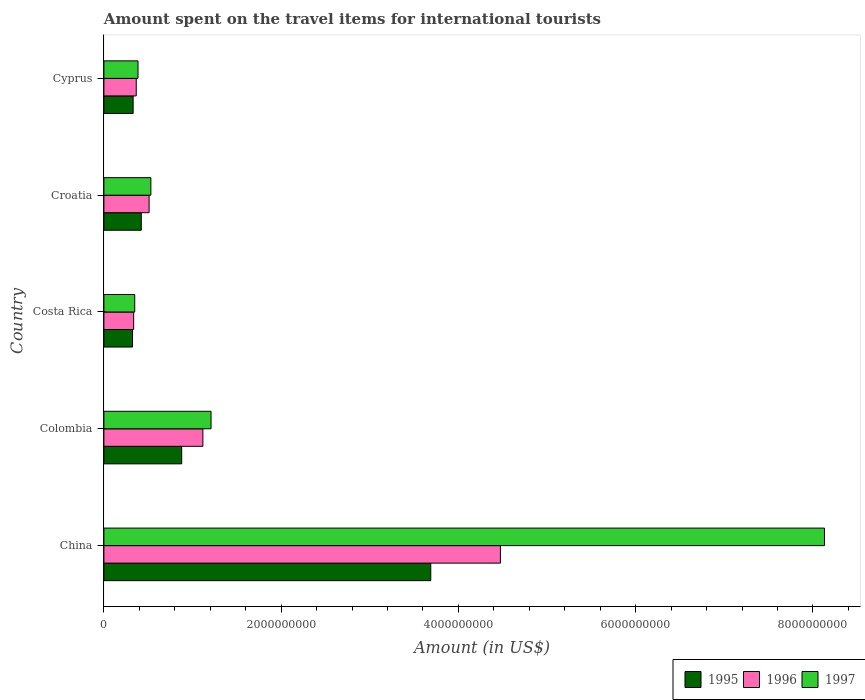How many different coloured bars are there?
Offer a terse response. 3. How many groups of bars are there?
Offer a terse response. 5. Are the number of bars on each tick of the Y-axis equal?
Your response must be concise. Yes. How many bars are there on the 5th tick from the top?
Provide a short and direct response. 3. What is the amount spent on the travel items for international tourists in 1995 in China?
Provide a short and direct response. 3.69e+09. Across all countries, what is the maximum amount spent on the travel items for international tourists in 1996?
Provide a short and direct response. 4.47e+09. Across all countries, what is the minimum amount spent on the travel items for international tourists in 1995?
Provide a short and direct response. 3.23e+08. In which country was the amount spent on the travel items for international tourists in 1996 minimum?
Provide a succinct answer. Costa Rica. What is the total amount spent on the travel items for international tourists in 1997 in the graph?
Offer a very short reply. 1.06e+1. What is the difference between the amount spent on the travel items for international tourists in 1995 in Costa Rica and that in Croatia?
Your answer should be very brief. -9.90e+07. What is the difference between the amount spent on the travel items for international tourists in 1997 in Costa Rica and the amount spent on the travel items for international tourists in 1995 in Colombia?
Keep it short and to the point. -5.30e+08. What is the average amount spent on the travel items for international tourists in 1996 per country?
Offer a very short reply. 1.36e+09. What is the difference between the amount spent on the travel items for international tourists in 1997 and amount spent on the travel items for international tourists in 1996 in China?
Your answer should be compact. 3.66e+09. In how many countries, is the amount spent on the travel items for international tourists in 1996 greater than 2400000000 US$?
Offer a very short reply. 1. What is the ratio of the amount spent on the travel items for international tourists in 1995 in Colombia to that in Cyprus?
Your answer should be very brief. 2.66. Is the difference between the amount spent on the travel items for international tourists in 1997 in China and Cyprus greater than the difference between the amount spent on the travel items for international tourists in 1996 in China and Cyprus?
Ensure brevity in your answer.  Yes. What is the difference between the highest and the second highest amount spent on the travel items for international tourists in 1996?
Keep it short and to the point. 3.36e+09. What is the difference between the highest and the lowest amount spent on the travel items for international tourists in 1995?
Offer a terse response. 3.36e+09. Is the sum of the amount spent on the travel items for international tourists in 1995 in China and Colombia greater than the maximum amount spent on the travel items for international tourists in 1997 across all countries?
Ensure brevity in your answer.  No. What does the 3rd bar from the top in Cyprus represents?
Your answer should be very brief. 1995. What does the 1st bar from the bottom in China represents?
Your answer should be compact. 1995. How many countries are there in the graph?
Your answer should be compact. 5. Are the values on the major ticks of X-axis written in scientific E-notation?
Your response must be concise. No. Does the graph contain any zero values?
Offer a terse response. No. Where does the legend appear in the graph?
Give a very brief answer. Bottom right. How many legend labels are there?
Offer a very short reply. 3. What is the title of the graph?
Give a very brief answer. Amount spent on the travel items for international tourists. Does "1961" appear as one of the legend labels in the graph?
Your response must be concise. No. What is the Amount (in US$) in 1995 in China?
Give a very brief answer. 3.69e+09. What is the Amount (in US$) in 1996 in China?
Your response must be concise. 4.47e+09. What is the Amount (in US$) of 1997 in China?
Your answer should be compact. 8.13e+09. What is the Amount (in US$) of 1995 in Colombia?
Offer a very short reply. 8.78e+08. What is the Amount (in US$) in 1996 in Colombia?
Ensure brevity in your answer.  1.12e+09. What is the Amount (in US$) in 1997 in Colombia?
Offer a very short reply. 1.21e+09. What is the Amount (in US$) of 1995 in Costa Rica?
Your response must be concise. 3.23e+08. What is the Amount (in US$) of 1996 in Costa Rica?
Offer a terse response. 3.36e+08. What is the Amount (in US$) of 1997 in Costa Rica?
Provide a succinct answer. 3.48e+08. What is the Amount (in US$) in 1995 in Croatia?
Ensure brevity in your answer.  4.22e+08. What is the Amount (in US$) of 1996 in Croatia?
Your answer should be compact. 5.10e+08. What is the Amount (in US$) in 1997 in Croatia?
Ensure brevity in your answer.  5.30e+08. What is the Amount (in US$) in 1995 in Cyprus?
Provide a short and direct response. 3.30e+08. What is the Amount (in US$) of 1996 in Cyprus?
Your answer should be compact. 3.65e+08. What is the Amount (in US$) of 1997 in Cyprus?
Your answer should be compact. 3.85e+08. Across all countries, what is the maximum Amount (in US$) of 1995?
Provide a succinct answer. 3.69e+09. Across all countries, what is the maximum Amount (in US$) in 1996?
Make the answer very short. 4.47e+09. Across all countries, what is the maximum Amount (in US$) of 1997?
Offer a terse response. 8.13e+09. Across all countries, what is the minimum Amount (in US$) of 1995?
Ensure brevity in your answer.  3.23e+08. Across all countries, what is the minimum Amount (in US$) in 1996?
Keep it short and to the point. 3.36e+08. Across all countries, what is the minimum Amount (in US$) in 1997?
Offer a very short reply. 3.48e+08. What is the total Amount (in US$) of 1995 in the graph?
Give a very brief answer. 5.64e+09. What is the total Amount (in US$) of 1996 in the graph?
Provide a short and direct response. 6.80e+09. What is the total Amount (in US$) in 1997 in the graph?
Your answer should be compact. 1.06e+1. What is the difference between the Amount (in US$) of 1995 in China and that in Colombia?
Make the answer very short. 2.81e+09. What is the difference between the Amount (in US$) in 1996 in China and that in Colombia?
Provide a succinct answer. 3.36e+09. What is the difference between the Amount (in US$) of 1997 in China and that in Colombia?
Provide a succinct answer. 6.92e+09. What is the difference between the Amount (in US$) in 1995 in China and that in Costa Rica?
Provide a short and direct response. 3.36e+09. What is the difference between the Amount (in US$) of 1996 in China and that in Costa Rica?
Make the answer very short. 4.14e+09. What is the difference between the Amount (in US$) of 1997 in China and that in Costa Rica?
Give a very brief answer. 7.78e+09. What is the difference between the Amount (in US$) of 1995 in China and that in Croatia?
Your answer should be compact. 3.27e+09. What is the difference between the Amount (in US$) of 1996 in China and that in Croatia?
Your answer should be very brief. 3.96e+09. What is the difference between the Amount (in US$) of 1997 in China and that in Croatia?
Ensure brevity in your answer.  7.60e+09. What is the difference between the Amount (in US$) in 1995 in China and that in Cyprus?
Keep it short and to the point. 3.36e+09. What is the difference between the Amount (in US$) in 1996 in China and that in Cyprus?
Provide a succinct answer. 4.11e+09. What is the difference between the Amount (in US$) in 1997 in China and that in Cyprus?
Provide a succinct answer. 7.74e+09. What is the difference between the Amount (in US$) in 1995 in Colombia and that in Costa Rica?
Ensure brevity in your answer.  5.55e+08. What is the difference between the Amount (in US$) of 1996 in Colombia and that in Costa Rica?
Your answer should be very brief. 7.81e+08. What is the difference between the Amount (in US$) of 1997 in Colombia and that in Costa Rica?
Ensure brevity in your answer.  8.61e+08. What is the difference between the Amount (in US$) in 1995 in Colombia and that in Croatia?
Give a very brief answer. 4.56e+08. What is the difference between the Amount (in US$) in 1996 in Colombia and that in Croatia?
Your answer should be compact. 6.07e+08. What is the difference between the Amount (in US$) in 1997 in Colombia and that in Croatia?
Your answer should be very brief. 6.79e+08. What is the difference between the Amount (in US$) of 1995 in Colombia and that in Cyprus?
Your answer should be very brief. 5.48e+08. What is the difference between the Amount (in US$) of 1996 in Colombia and that in Cyprus?
Give a very brief answer. 7.52e+08. What is the difference between the Amount (in US$) in 1997 in Colombia and that in Cyprus?
Make the answer very short. 8.24e+08. What is the difference between the Amount (in US$) of 1995 in Costa Rica and that in Croatia?
Offer a very short reply. -9.90e+07. What is the difference between the Amount (in US$) in 1996 in Costa Rica and that in Croatia?
Your response must be concise. -1.74e+08. What is the difference between the Amount (in US$) in 1997 in Costa Rica and that in Croatia?
Make the answer very short. -1.82e+08. What is the difference between the Amount (in US$) of 1995 in Costa Rica and that in Cyprus?
Your answer should be very brief. -7.00e+06. What is the difference between the Amount (in US$) of 1996 in Costa Rica and that in Cyprus?
Your response must be concise. -2.90e+07. What is the difference between the Amount (in US$) in 1997 in Costa Rica and that in Cyprus?
Provide a short and direct response. -3.70e+07. What is the difference between the Amount (in US$) of 1995 in Croatia and that in Cyprus?
Your response must be concise. 9.20e+07. What is the difference between the Amount (in US$) of 1996 in Croatia and that in Cyprus?
Your answer should be compact. 1.45e+08. What is the difference between the Amount (in US$) in 1997 in Croatia and that in Cyprus?
Your answer should be very brief. 1.45e+08. What is the difference between the Amount (in US$) in 1995 in China and the Amount (in US$) in 1996 in Colombia?
Give a very brief answer. 2.57e+09. What is the difference between the Amount (in US$) of 1995 in China and the Amount (in US$) of 1997 in Colombia?
Offer a very short reply. 2.48e+09. What is the difference between the Amount (in US$) of 1996 in China and the Amount (in US$) of 1997 in Colombia?
Offer a very short reply. 3.26e+09. What is the difference between the Amount (in US$) of 1995 in China and the Amount (in US$) of 1996 in Costa Rica?
Make the answer very short. 3.35e+09. What is the difference between the Amount (in US$) in 1995 in China and the Amount (in US$) in 1997 in Costa Rica?
Make the answer very short. 3.34e+09. What is the difference between the Amount (in US$) of 1996 in China and the Amount (in US$) of 1997 in Costa Rica?
Give a very brief answer. 4.13e+09. What is the difference between the Amount (in US$) of 1995 in China and the Amount (in US$) of 1996 in Croatia?
Provide a succinct answer. 3.18e+09. What is the difference between the Amount (in US$) in 1995 in China and the Amount (in US$) in 1997 in Croatia?
Offer a very short reply. 3.16e+09. What is the difference between the Amount (in US$) of 1996 in China and the Amount (in US$) of 1997 in Croatia?
Your response must be concise. 3.94e+09. What is the difference between the Amount (in US$) in 1995 in China and the Amount (in US$) in 1996 in Cyprus?
Keep it short and to the point. 3.32e+09. What is the difference between the Amount (in US$) of 1995 in China and the Amount (in US$) of 1997 in Cyprus?
Offer a very short reply. 3.30e+09. What is the difference between the Amount (in US$) of 1996 in China and the Amount (in US$) of 1997 in Cyprus?
Your answer should be compact. 4.09e+09. What is the difference between the Amount (in US$) of 1995 in Colombia and the Amount (in US$) of 1996 in Costa Rica?
Your answer should be compact. 5.42e+08. What is the difference between the Amount (in US$) in 1995 in Colombia and the Amount (in US$) in 1997 in Costa Rica?
Provide a short and direct response. 5.30e+08. What is the difference between the Amount (in US$) in 1996 in Colombia and the Amount (in US$) in 1997 in Costa Rica?
Your answer should be very brief. 7.69e+08. What is the difference between the Amount (in US$) in 1995 in Colombia and the Amount (in US$) in 1996 in Croatia?
Make the answer very short. 3.68e+08. What is the difference between the Amount (in US$) in 1995 in Colombia and the Amount (in US$) in 1997 in Croatia?
Your answer should be compact. 3.48e+08. What is the difference between the Amount (in US$) of 1996 in Colombia and the Amount (in US$) of 1997 in Croatia?
Provide a succinct answer. 5.87e+08. What is the difference between the Amount (in US$) in 1995 in Colombia and the Amount (in US$) in 1996 in Cyprus?
Ensure brevity in your answer.  5.13e+08. What is the difference between the Amount (in US$) in 1995 in Colombia and the Amount (in US$) in 1997 in Cyprus?
Offer a terse response. 4.93e+08. What is the difference between the Amount (in US$) in 1996 in Colombia and the Amount (in US$) in 1997 in Cyprus?
Your answer should be compact. 7.32e+08. What is the difference between the Amount (in US$) of 1995 in Costa Rica and the Amount (in US$) of 1996 in Croatia?
Offer a terse response. -1.87e+08. What is the difference between the Amount (in US$) of 1995 in Costa Rica and the Amount (in US$) of 1997 in Croatia?
Provide a succinct answer. -2.07e+08. What is the difference between the Amount (in US$) in 1996 in Costa Rica and the Amount (in US$) in 1997 in Croatia?
Give a very brief answer. -1.94e+08. What is the difference between the Amount (in US$) in 1995 in Costa Rica and the Amount (in US$) in 1996 in Cyprus?
Your answer should be very brief. -4.20e+07. What is the difference between the Amount (in US$) of 1995 in Costa Rica and the Amount (in US$) of 1997 in Cyprus?
Keep it short and to the point. -6.20e+07. What is the difference between the Amount (in US$) of 1996 in Costa Rica and the Amount (in US$) of 1997 in Cyprus?
Make the answer very short. -4.90e+07. What is the difference between the Amount (in US$) in 1995 in Croatia and the Amount (in US$) in 1996 in Cyprus?
Keep it short and to the point. 5.70e+07. What is the difference between the Amount (in US$) of 1995 in Croatia and the Amount (in US$) of 1997 in Cyprus?
Your answer should be compact. 3.70e+07. What is the difference between the Amount (in US$) of 1996 in Croatia and the Amount (in US$) of 1997 in Cyprus?
Give a very brief answer. 1.25e+08. What is the average Amount (in US$) of 1995 per country?
Your answer should be very brief. 1.13e+09. What is the average Amount (in US$) in 1996 per country?
Make the answer very short. 1.36e+09. What is the average Amount (in US$) in 1997 per country?
Offer a terse response. 2.12e+09. What is the difference between the Amount (in US$) in 1995 and Amount (in US$) in 1996 in China?
Your answer should be compact. -7.86e+08. What is the difference between the Amount (in US$) in 1995 and Amount (in US$) in 1997 in China?
Provide a succinct answer. -4.44e+09. What is the difference between the Amount (in US$) of 1996 and Amount (in US$) of 1997 in China?
Your answer should be compact. -3.66e+09. What is the difference between the Amount (in US$) of 1995 and Amount (in US$) of 1996 in Colombia?
Make the answer very short. -2.39e+08. What is the difference between the Amount (in US$) in 1995 and Amount (in US$) in 1997 in Colombia?
Give a very brief answer. -3.31e+08. What is the difference between the Amount (in US$) in 1996 and Amount (in US$) in 1997 in Colombia?
Your answer should be very brief. -9.20e+07. What is the difference between the Amount (in US$) in 1995 and Amount (in US$) in 1996 in Costa Rica?
Give a very brief answer. -1.30e+07. What is the difference between the Amount (in US$) in 1995 and Amount (in US$) in 1997 in Costa Rica?
Provide a succinct answer. -2.50e+07. What is the difference between the Amount (in US$) in 1996 and Amount (in US$) in 1997 in Costa Rica?
Your answer should be compact. -1.20e+07. What is the difference between the Amount (in US$) in 1995 and Amount (in US$) in 1996 in Croatia?
Your response must be concise. -8.80e+07. What is the difference between the Amount (in US$) of 1995 and Amount (in US$) of 1997 in Croatia?
Keep it short and to the point. -1.08e+08. What is the difference between the Amount (in US$) in 1996 and Amount (in US$) in 1997 in Croatia?
Ensure brevity in your answer.  -2.00e+07. What is the difference between the Amount (in US$) of 1995 and Amount (in US$) of 1996 in Cyprus?
Provide a succinct answer. -3.50e+07. What is the difference between the Amount (in US$) in 1995 and Amount (in US$) in 1997 in Cyprus?
Offer a very short reply. -5.50e+07. What is the difference between the Amount (in US$) in 1996 and Amount (in US$) in 1997 in Cyprus?
Your answer should be very brief. -2.00e+07. What is the ratio of the Amount (in US$) of 1995 in China to that in Colombia?
Offer a very short reply. 4.2. What is the ratio of the Amount (in US$) in 1996 in China to that in Colombia?
Your answer should be very brief. 4.01. What is the ratio of the Amount (in US$) in 1997 in China to that in Colombia?
Provide a succinct answer. 6.72. What is the ratio of the Amount (in US$) in 1995 in China to that in Costa Rica?
Ensure brevity in your answer.  11.42. What is the ratio of the Amount (in US$) in 1996 in China to that in Costa Rica?
Your answer should be very brief. 13.32. What is the ratio of the Amount (in US$) of 1997 in China to that in Costa Rica?
Offer a very short reply. 23.36. What is the ratio of the Amount (in US$) of 1995 in China to that in Croatia?
Your answer should be compact. 8.74. What is the ratio of the Amount (in US$) of 1996 in China to that in Croatia?
Ensure brevity in your answer.  8.77. What is the ratio of the Amount (in US$) in 1997 in China to that in Croatia?
Your answer should be very brief. 15.34. What is the ratio of the Amount (in US$) of 1995 in China to that in Cyprus?
Give a very brief answer. 11.18. What is the ratio of the Amount (in US$) in 1996 in China to that in Cyprus?
Give a very brief answer. 12.26. What is the ratio of the Amount (in US$) of 1997 in China to that in Cyprus?
Your answer should be very brief. 21.12. What is the ratio of the Amount (in US$) of 1995 in Colombia to that in Costa Rica?
Ensure brevity in your answer.  2.72. What is the ratio of the Amount (in US$) in 1996 in Colombia to that in Costa Rica?
Ensure brevity in your answer.  3.32. What is the ratio of the Amount (in US$) in 1997 in Colombia to that in Costa Rica?
Your answer should be compact. 3.47. What is the ratio of the Amount (in US$) of 1995 in Colombia to that in Croatia?
Your answer should be compact. 2.08. What is the ratio of the Amount (in US$) of 1996 in Colombia to that in Croatia?
Your response must be concise. 2.19. What is the ratio of the Amount (in US$) of 1997 in Colombia to that in Croatia?
Make the answer very short. 2.28. What is the ratio of the Amount (in US$) in 1995 in Colombia to that in Cyprus?
Make the answer very short. 2.66. What is the ratio of the Amount (in US$) in 1996 in Colombia to that in Cyprus?
Your response must be concise. 3.06. What is the ratio of the Amount (in US$) of 1997 in Colombia to that in Cyprus?
Give a very brief answer. 3.14. What is the ratio of the Amount (in US$) of 1995 in Costa Rica to that in Croatia?
Provide a short and direct response. 0.77. What is the ratio of the Amount (in US$) in 1996 in Costa Rica to that in Croatia?
Provide a short and direct response. 0.66. What is the ratio of the Amount (in US$) in 1997 in Costa Rica to that in Croatia?
Your answer should be compact. 0.66. What is the ratio of the Amount (in US$) of 1995 in Costa Rica to that in Cyprus?
Make the answer very short. 0.98. What is the ratio of the Amount (in US$) of 1996 in Costa Rica to that in Cyprus?
Ensure brevity in your answer.  0.92. What is the ratio of the Amount (in US$) of 1997 in Costa Rica to that in Cyprus?
Your answer should be compact. 0.9. What is the ratio of the Amount (in US$) of 1995 in Croatia to that in Cyprus?
Your answer should be compact. 1.28. What is the ratio of the Amount (in US$) of 1996 in Croatia to that in Cyprus?
Your response must be concise. 1.4. What is the ratio of the Amount (in US$) in 1997 in Croatia to that in Cyprus?
Your response must be concise. 1.38. What is the difference between the highest and the second highest Amount (in US$) in 1995?
Give a very brief answer. 2.81e+09. What is the difference between the highest and the second highest Amount (in US$) in 1996?
Ensure brevity in your answer.  3.36e+09. What is the difference between the highest and the second highest Amount (in US$) of 1997?
Your response must be concise. 6.92e+09. What is the difference between the highest and the lowest Amount (in US$) of 1995?
Your answer should be compact. 3.36e+09. What is the difference between the highest and the lowest Amount (in US$) of 1996?
Offer a terse response. 4.14e+09. What is the difference between the highest and the lowest Amount (in US$) in 1997?
Give a very brief answer. 7.78e+09. 